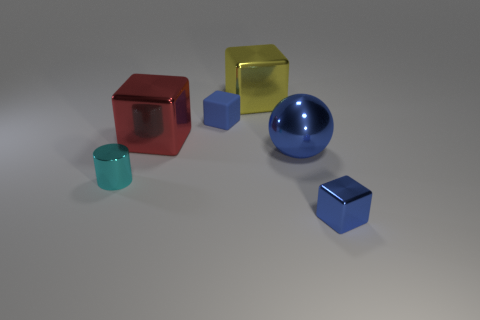There is a blue sphere that is the same size as the yellow metallic object; what is it made of?
Give a very brief answer. Metal. What number of other objects are the same material as the big sphere?
Make the answer very short. 4. Are there an equal number of large yellow cubes and tiny blue cylinders?
Your response must be concise. No. There is a metal block that is behind the metallic cylinder and on the right side of the red metal cube; what color is it?
Give a very brief answer. Yellow. How many things are either blocks that are left of the yellow thing or big brown metallic balls?
Offer a terse response. 2. What number of other objects are there of the same color as the metal cylinder?
Make the answer very short. 0. Are there an equal number of blue matte things that are behind the blue matte block and small cyan things?
Provide a short and direct response. No. What number of tiny cubes are behind the tiny blue cube behind the blue metal thing behind the tiny cyan cylinder?
Give a very brief answer. 0. Is there anything else that is the same size as the yellow thing?
Offer a terse response. Yes. Does the red shiny cube have the same size as the blue cube to the left of the large blue thing?
Offer a very short reply. No. 